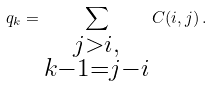<formula> <loc_0><loc_0><loc_500><loc_500>q _ { k } = \sum _ { \substack { j > i , \\ k - 1 = j - i } } C ( i , j ) \, .</formula> 